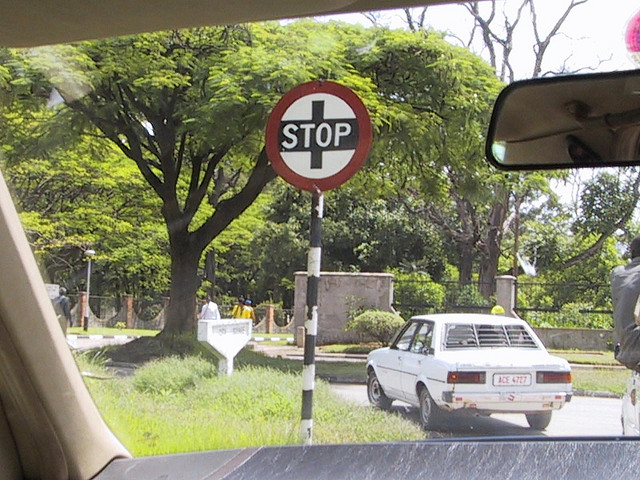<image>Who is following this person? I don't know who is following this person. It could be a car or a man. Who is following this person? I don't know who is following this person. It can be a car, a man, or someone in a car. 